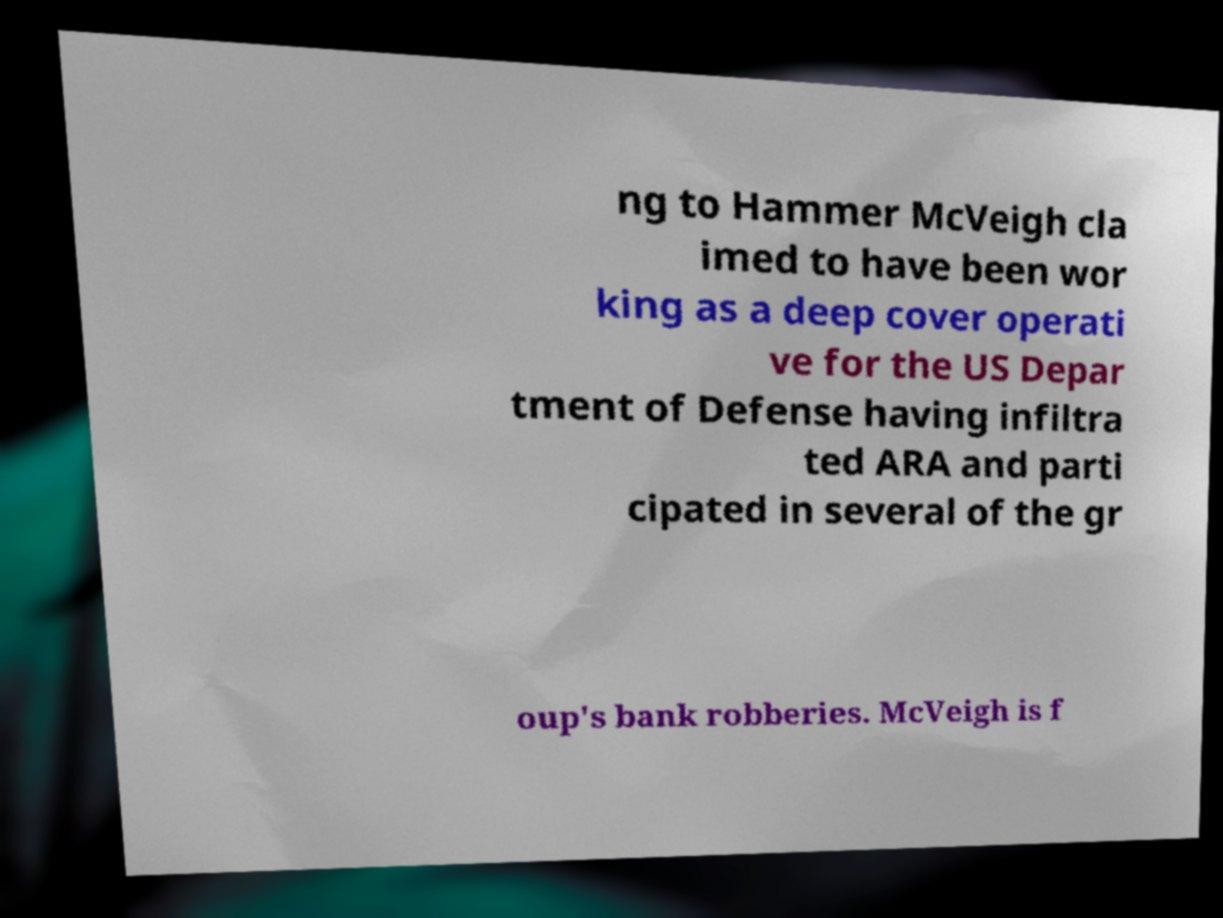Could you extract and type out the text from this image? ng to Hammer McVeigh cla imed to have been wor king as a deep cover operati ve for the US Depar tment of Defense having infiltra ted ARA and parti cipated in several of the gr oup's bank robberies. McVeigh is f 